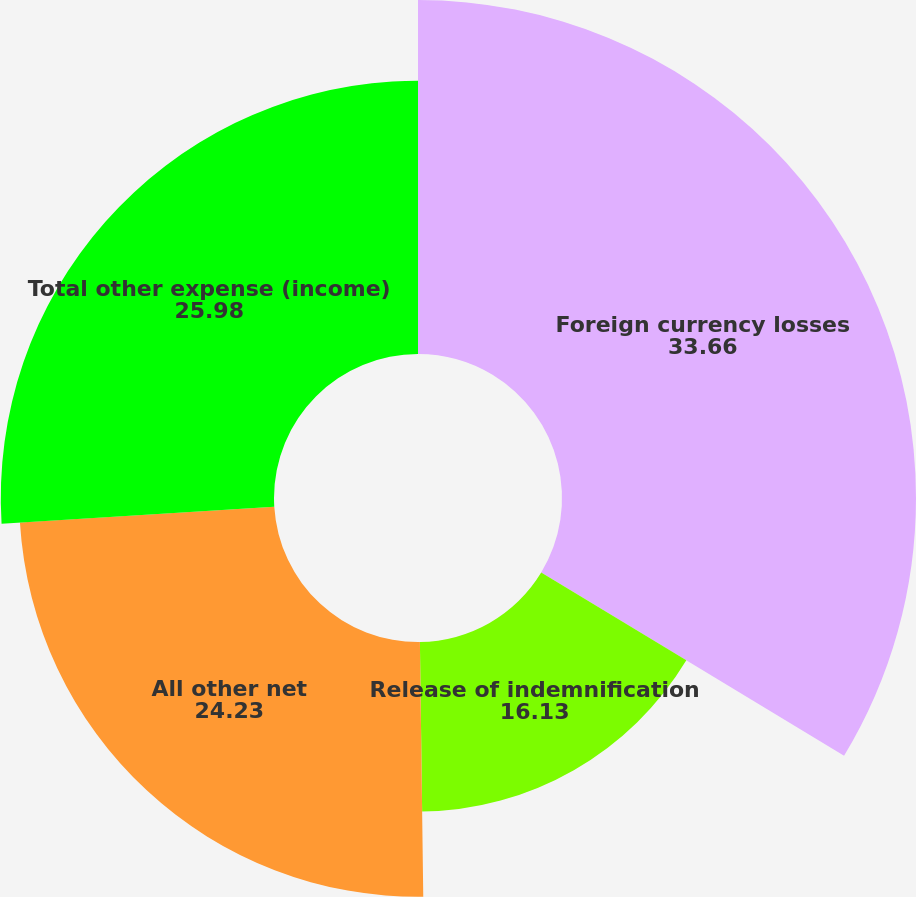Convert chart to OTSL. <chart><loc_0><loc_0><loc_500><loc_500><pie_chart><fcel>Foreign currency losses<fcel>Release of indemnification<fcel>All other net<fcel>Total other expense (income)<nl><fcel>33.66%<fcel>16.13%<fcel>24.23%<fcel>25.98%<nl></chart> 